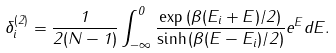<formula> <loc_0><loc_0><loc_500><loc_500>\delta ^ { ( 2 ) } _ { i } = \frac { 1 } { 2 ( N - 1 ) } \int _ { - \infty } ^ { 0 } \frac { \exp { ( \beta ( E _ { i } + E ) / 2 ) } } { \sinh { ( \beta ( E - E _ { i } ) / 2 ) } } e ^ { E } d E .</formula> 